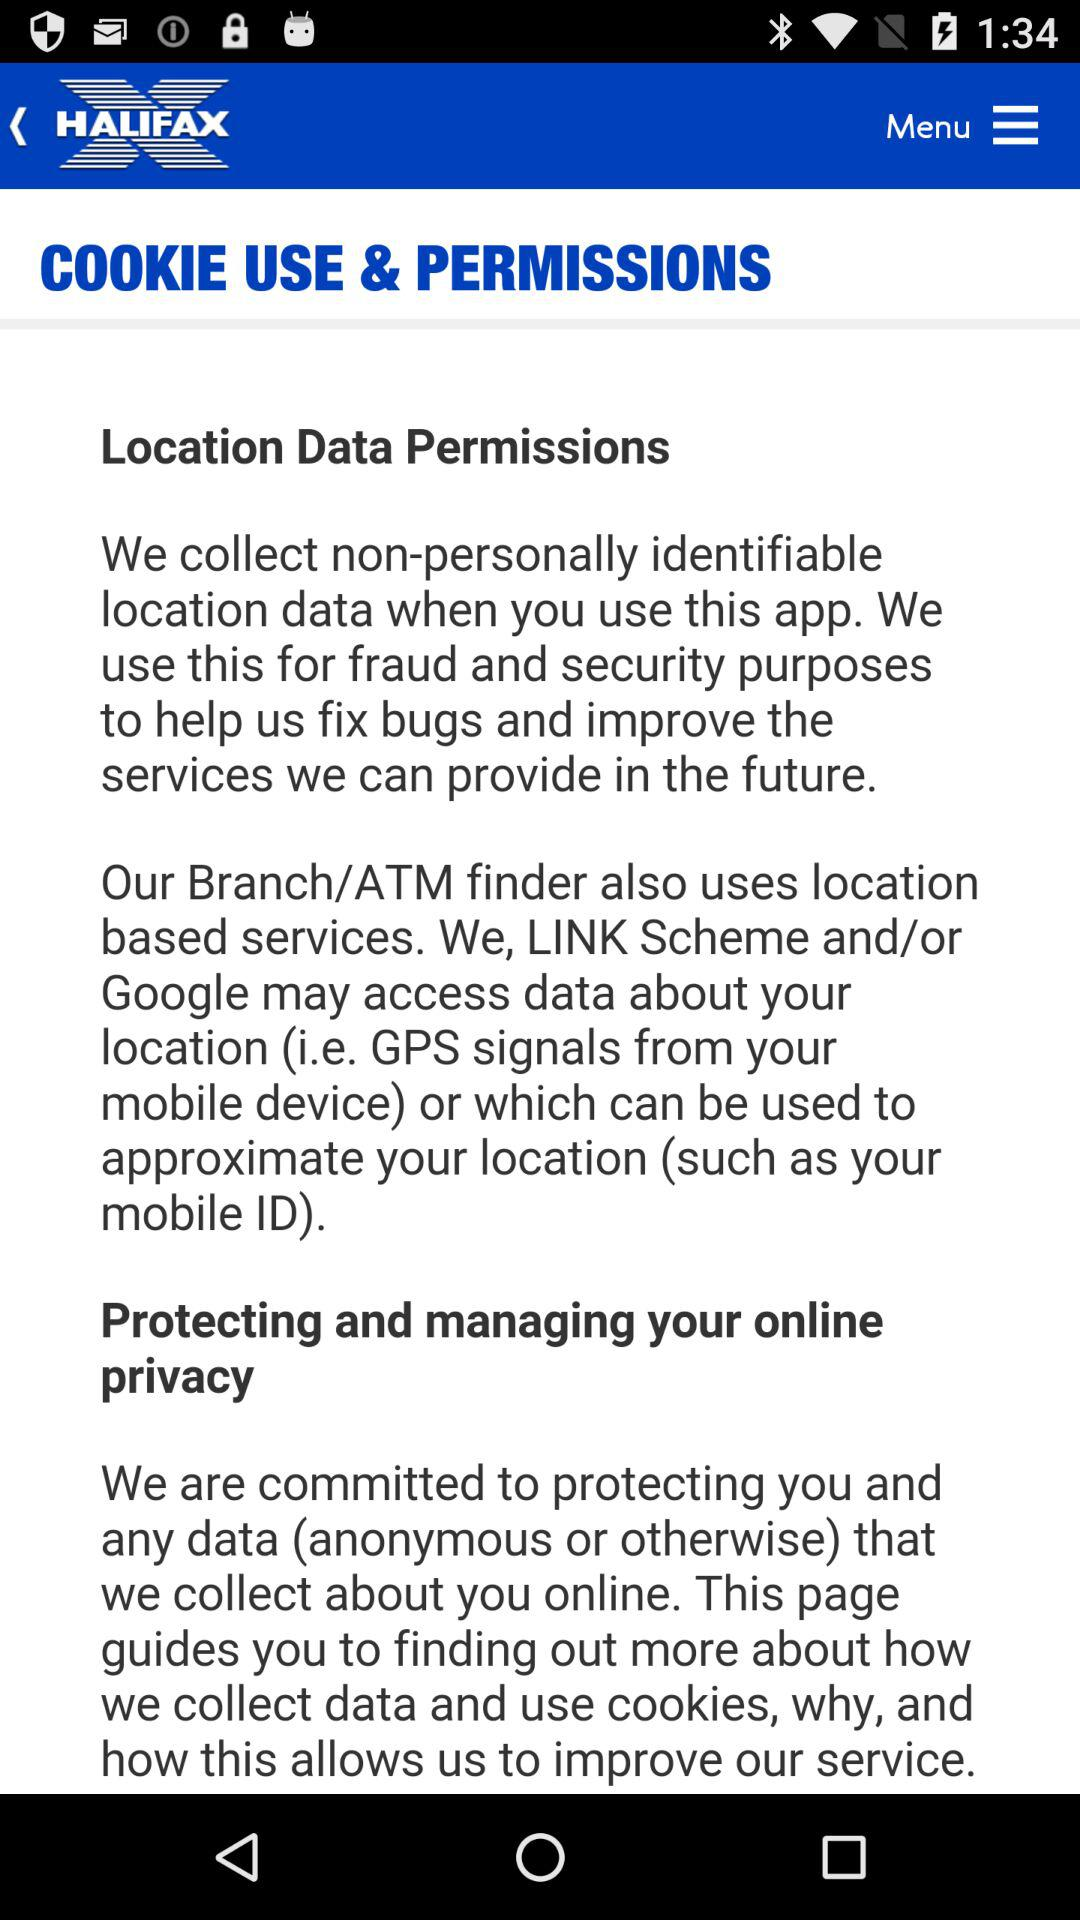What is the name of the application? The name of the application is "Halifax Mobile Banking". 